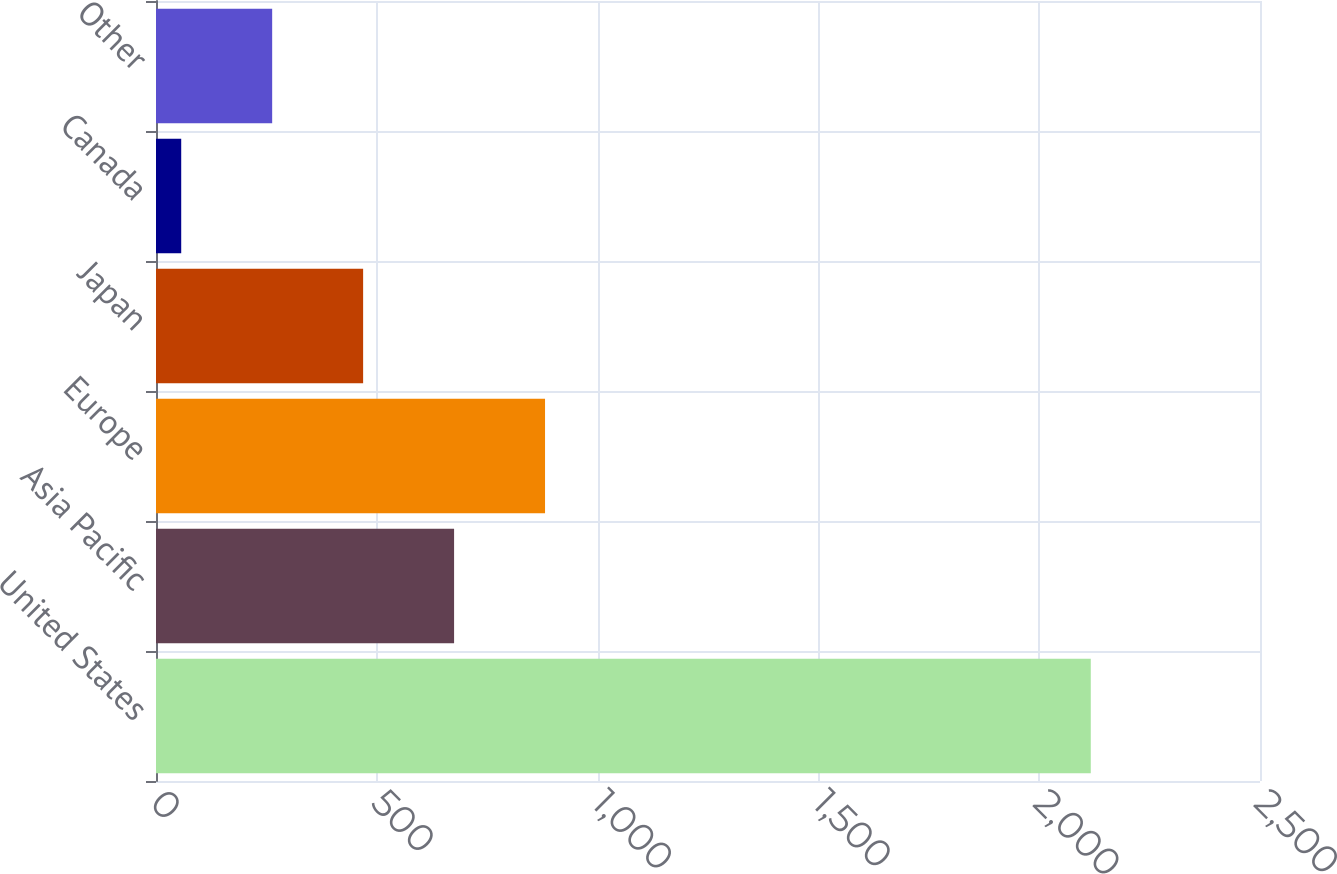Convert chart to OTSL. <chart><loc_0><loc_0><loc_500><loc_500><bar_chart><fcel>United States<fcel>Asia Pacific<fcel>Europe<fcel>Japan<fcel>Canada<fcel>Other<nl><fcel>2116.8<fcel>675.01<fcel>880.98<fcel>469.04<fcel>57.1<fcel>263.07<nl></chart> 